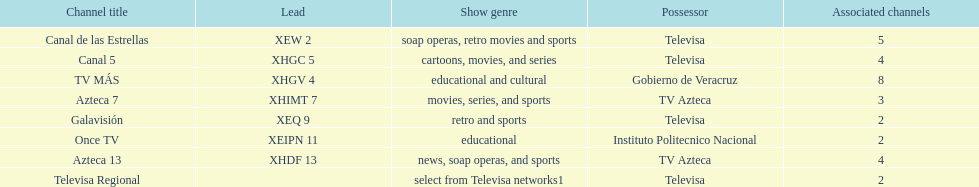Who has the most number of affiliates? TV MÁS. 